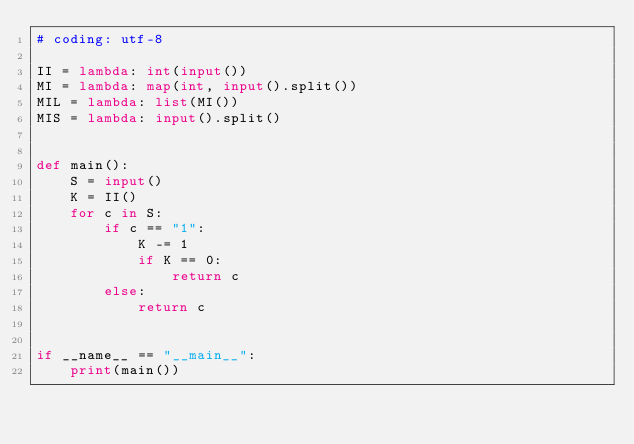Convert code to text. <code><loc_0><loc_0><loc_500><loc_500><_Python_># coding: utf-8

II = lambda: int(input())
MI = lambda: map(int, input().split())
MIL = lambda: list(MI())
MIS = lambda: input().split()


def main():
    S = input()
    K = II()
    for c in S:
        if c == "1":
            K -= 1
            if K == 0:
                return c
        else:
            return c


if __name__ == "__main__":
    print(main())
</code> 